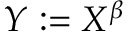<formula> <loc_0><loc_0><loc_500><loc_500>Y \colon = X ^ { \beta }</formula> 